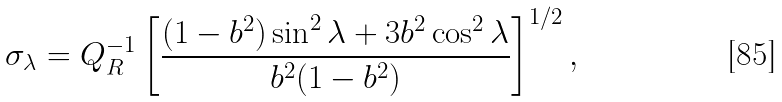Convert formula to latex. <formula><loc_0><loc_0><loc_500><loc_500>\sigma _ { \lambda } = Q _ { R } ^ { - 1 } \left [ \frac { ( 1 - b ^ { 2 } ) \sin ^ { 2 } { \lambda } + 3 b ^ { 2 } \cos ^ { 2 } { \lambda } } { b ^ { 2 } ( 1 - b ^ { 2 } ) } \right ] ^ { 1 / 2 } ,</formula> 